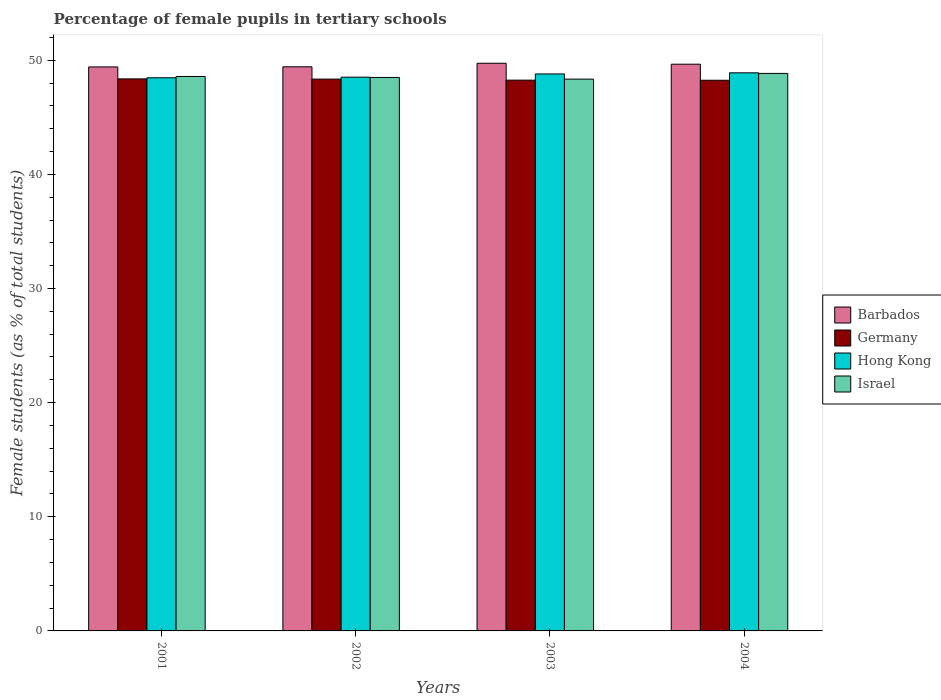How many groups of bars are there?
Ensure brevity in your answer.  4. Are the number of bars per tick equal to the number of legend labels?
Offer a terse response. Yes. How many bars are there on the 1st tick from the left?
Give a very brief answer. 4. What is the label of the 1st group of bars from the left?
Make the answer very short. 2001. In how many cases, is the number of bars for a given year not equal to the number of legend labels?
Your answer should be compact. 0. What is the percentage of female pupils in tertiary schools in Barbados in 2004?
Ensure brevity in your answer.  49.65. Across all years, what is the maximum percentage of female pupils in tertiary schools in Israel?
Your response must be concise. 48.85. Across all years, what is the minimum percentage of female pupils in tertiary schools in Barbados?
Your answer should be compact. 49.42. In which year was the percentage of female pupils in tertiary schools in Israel minimum?
Provide a succinct answer. 2003. What is the total percentage of female pupils in tertiary schools in Hong Kong in the graph?
Give a very brief answer. 194.67. What is the difference between the percentage of female pupils in tertiary schools in Israel in 2002 and that in 2004?
Provide a succinct answer. -0.35. What is the difference between the percentage of female pupils in tertiary schools in Israel in 2001 and the percentage of female pupils in tertiary schools in Barbados in 2002?
Ensure brevity in your answer.  -0.85. What is the average percentage of female pupils in tertiary schools in Israel per year?
Your answer should be compact. 48.56. In the year 2001, what is the difference between the percentage of female pupils in tertiary schools in Israel and percentage of female pupils in tertiary schools in Barbados?
Your answer should be compact. -0.84. In how many years, is the percentage of female pupils in tertiary schools in Israel greater than 16 %?
Offer a terse response. 4. What is the ratio of the percentage of female pupils in tertiary schools in Hong Kong in 2001 to that in 2004?
Provide a short and direct response. 0.99. Is the percentage of female pupils in tertiary schools in Hong Kong in 2002 less than that in 2004?
Ensure brevity in your answer.  Yes. What is the difference between the highest and the second highest percentage of female pupils in tertiary schools in Hong Kong?
Keep it short and to the point. 0.1. What is the difference between the highest and the lowest percentage of female pupils in tertiary schools in Germany?
Offer a terse response. 0.12. Is the sum of the percentage of female pupils in tertiary schools in Israel in 2002 and 2004 greater than the maximum percentage of female pupils in tertiary schools in Germany across all years?
Offer a terse response. Yes. Is it the case that in every year, the sum of the percentage of female pupils in tertiary schools in Israel and percentage of female pupils in tertiary schools in Barbados is greater than the sum of percentage of female pupils in tertiary schools in Hong Kong and percentage of female pupils in tertiary schools in Germany?
Give a very brief answer. No. How many bars are there?
Give a very brief answer. 16. Are all the bars in the graph horizontal?
Offer a terse response. No. Does the graph contain any zero values?
Give a very brief answer. No. How are the legend labels stacked?
Provide a short and direct response. Vertical. What is the title of the graph?
Provide a succinct answer. Percentage of female pupils in tertiary schools. Does "East Asia (developing only)" appear as one of the legend labels in the graph?
Make the answer very short. No. What is the label or title of the X-axis?
Your response must be concise. Years. What is the label or title of the Y-axis?
Give a very brief answer. Female students (as % of total students). What is the Female students (as % of total students) of Barbados in 2001?
Provide a succinct answer. 49.42. What is the Female students (as % of total students) of Germany in 2001?
Your response must be concise. 48.37. What is the Female students (as % of total students) of Hong Kong in 2001?
Your answer should be compact. 48.46. What is the Female students (as % of total students) in Israel in 2001?
Offer a terse response. 48.58. What is the Female students (as % of total students) of Barbados in 2002?
Offer a very short reply. 49.43. What is the Female students (as % of total students) in Germany in 2002?
Keep it short and to the point. 48.35. What is the Female students (as % of total students) of Hong Kong in 2002?
Make the answer very short. 48.51. What is the Female students (as % of total students) of Israel in 2002?
Give a very brief answer. 48.49. What is the Female students (as % of total students) in Barbados in 2003?
Keep it short and to the point. 49.74. What is the Female students (as % of total students) of Germany in 2003?
Your answer should be very brief. 48.25. What is the Female students (as % of total students) in Hong Kong in 2003?
Give a very brief answer. 48.8. What is the Female students (as % of total students) of Israel in 2003?
Give a very brief answer. 48.35. What is the Female students (as % of total students) of Barbados in 2004?
Make the answer very short. 49.65. What is the Female students (as % of total students) of Germany in 2004?
Offer a very short reply. 48.24. What is the Female students (as % of total students) in Hong Kong in 2004?
Your answer should be very brief. 48.9. What is the Female students (as % of total students) in Israel in 2004?
Keep it short and to the point. 48.85. Across all years, what is the maximum Female students (as % of total students) of Barbados?
Offer a terse response. 49.74. Across all years, what is the maximum Female students (as % of total students) in Germany?
Your answer should be very brief. 48.37. Across all years, what is the maximum Female students (as % of total students) of Hong Kong?
Offer a terse response. 48.9. Across all years, what is the maximum Female students (as % of total students) of Israel?
Give a very brief answer. 48.85. Across all years, what is the minimum Female students (as % of total students) in Barbados?
Give a very brief answer. 49.42. Across all years, what is the minimum Female students (as % of total students) of Germany?
Ensure brevity in your answer.  48.24. Across all years, what is the minimum Female students (as % of total students) of Hong Kong?
Ensure brevity in your answer.  48.46. Across all years, what is the minimum Female students (as % of total students) in Israel?
Your answer should be very brief. 48.35. What is the total Female students (as % of total students) in Barbados in the graph?
Make the answer very short. 198.23. What is the total Female students (as % of total students) in Germany in the graph?
Provide a succinct answer. 193.21. What is the total Female students (as % of total students) in Hong Kong in the graph?
Offer a terse response. 194.67. What is the total Female students (as % of total students) in Israel in the graph?
Your answer should be very brief. 194.26. What is the difference between the Female students (as % of total students) of Barbados in 2001 and that in 2002?
Give a very brief answer. -0.01. What is the difference between the Female students (as % of total students) of Germany in 2001 and that in 2002?
Keep it short and to the point. 0.02. What is the difference between the Female students (as % of total students) in Hong Kong in 2001 and that in 2002?
Give a very brief answer. -0.05. What is the difference between the Female students (as % of total students) of Israel in 2001 and that in 2002?
Your answer should be very brief. 0.08. What is the difference between the Female students (as % of total students) of Barbados in 2001 and that in 2003?
Offer a terse response. -0.32. What is the difference between the Female students (as % of total students) in Germany in 2001 and that in 2003?
Your response must be concise. 0.11. What is the difference between the Female students (as % of total students) in Hong Kong in 2001 and that in 2003?
Your answer should be very brief. -0.34. What is the difference between the Female students (as % of total students) of Israel in 2001 and that in 2003?
Provide a succinct answer. 0.23. What is the difference between the Female students (as % of total students) of Barbados in 2001 and that in 2004?
Provide a short and direct response. -0.24. What is the difference between the Female students (as % of total students) in Germany in 2001 and that in 2004?
Keep it short and to the point. 0.12. What is the difference between the Female students (as % of total students) of Hong Kong in 2001 and that in 2004?
Make the answer very short. -0.43. What is the difference between the Female students (as % of total students) of Israel in 2001 and that in 2004?
Your answer should be compact. -0.27. What is the difference between the Female students (as % of total students) in Barbados in 2002 and that in 2003?
Provide a succinct answer. -0.31. What is the difference between the Female students (as % of total students) of Germany in 2002 and that in 2003?
Offer a terse response. 0.09. What is the difference between the Female students (as % of total students) in Hong Kong in 2002 and that in 2003?
Your response must be concise. -0.28. What is the difference between the Female students (as % of total students) of Israel in 2002 and that in 2003?
Keep it short and to the point. 0.15. What is the difference between the Female students (as % of total students) of Barbados in 2002 and that in 2004?
Provide a short and direct response. -0.23. What is the difference between the Female students (as % of total students) of Germany in 2002 and that in 2004?
Your response must be concise. 0.1. What is the difference between the Female students (as % of total students) of Hong Kong in 2002 and that in 2004?
Provide a short and direct response. -0.38. What is the difference between the Female students (as % of total students) of Israel in 2002 and that in 2004?
Your answer should be compact. -0.35. What is the difference between the Female students (as % of total students) in Barbados in 2003 and that in 2004?
Offer a very short reply. 0.08. What is the difference between the Female students (as % of total students) of Germany in 2003 and that in 2004?
Offer a very short reply. 0.01. What is the difference between the Female students (as % of total students) of Hong Kong in 2003 and that in 2004?
Provide a short and direct response. -0.1. What is the difference between the Female students (as % of total students) of Israel in 2003 and that in 2004?
Offer a very short reply. -0.5. What is the difference between the Female students (as % of total students) of Barbados in 2001 and the Female students (as % of total students) of Germany in 2002?
Offer a terse response. 1.07. What is the difference between the Female students (as % of total students) of Barbados in 2001 and the Female students (as % of total students) of Hong Kong in 2002?
Make the answer very short. 0.9. What is the difference between the Female students (as % of total students) in Barbados in 2001 and the Female students (as % of total students) in Israel in 2002?
Offer a terse response. 0.92. What is the difference between the Female students (as % of total students) of Germany in 2001 and the Female students (as % of total students) of Hong Kong in 2002?
Your response must be concise. -0.15. What is the difference between the Female students (as % of total students) of Germany in 2001 and the Female students (as % of total students) of Israel in 2002?
Provide a short and direct response. -0.13. What is the difference between the Female students (as % of total students) in Hong Kong in 2001 and the Female students (as % of total students) in Israel in 2002?
Your response must be concise. -0.03. What is the difference between the Female students (as % of total students) in Barbados in 2001 and the Female students (as % of total students) in Germany in 2003?
Give a very brief answer. 1.16. What is the difference between the Female students (as % of total students) of Barbados in 2001 and the Female students (as % of total students) of Hong Kong in 2003?
Provide a short and direct response. 0.62. What is the difference between the Female students (as % of total students) of Barbados in 2001 and the Female students (as % of total students) of Israel in 2003?
Give a very brief answer. 1.07. What is the difference between the Female students (as % of total students) in Germany in 2001 and the Female students (as % of total students) in Hong Kong in 2003?
Offer a terse response. -0.43. What is the difference between the Female students (as % of total students) of Germany in 2001 and the Female students (as % of total students) of Israel in 2003?
Your answer should be very brief. 0.02. What is the difference between the Female students (as % of total students) in Hong Kong in 2001 and the Female students (as % of total students) in Israel in 2003?
Your response must be concise. 0.12. What is the difference between the Female students (as % of total students) of Barbados in 2001 and the Female students (as % of total students) of Germany in 2004?
Your response must be concise. 1.17. What is the difference between the Female students (as % of total students) of Barbados in 2001 and the Female students (as % of total students) of Hong Kong in 2004?
Provide a succinct answer. 0.52. What is the difference between the Female students (as % of total students) in Barbados in 2001 and the Female students (as % of total students) in Israel in 2004?
Make the answer very short. 0.57. What is the difference between the Female students (as % of total students) of Germany in 2001 and the Female students (as % of total students) of Hong Kong in 2004?
Your answer should be compact. -0.53. What is the difference between the Female students (as % of total students) of Germany in 2001 and the Female students (as % of total students) of Israel in 2004?
Offer a very short reply. -0.48. What is the difference between the Female students (as % of total students) of Hong Kong in 2001 and the Female students (as % of total students) of Israel in 2004?
Your response must be concise. -0.38. What is the difference between the Female students (as % of total students) in Barbados in 2002 and the Female students (as % of total students) in Germany in 2003?
Your response must be concise. 1.17. What is the difference between the Female students (as % of total students) of Barbados in 2002 and the Female students (as % of total students) of Hong Kong in 2003?
Offer a very short reply. 0.63. What is the difference between the Female students (as % of total students) of Barbados in 2002 and the Female students (as % of total students) of Israel in 2003?
Give a very brief answer. 1.08. What is the difference between the Female students (as % of total students) of Germany in 2002 and the Female students (as % of total students) of Hong Kong in 2003?
Your answer should be very brief. -0.45. What is the difference between the Female students (as % of total students) of Hong Kong in 2002 and the Female students (as % of total students) of Israel in 2003?
Your answer should be very brief. 0.17. What is the difference between the Female students (as % of total students) of Barbados in 2002 and the Female students (as % of total students) of Germany in 2004?
Make the answer very short. 1.18. What is the difference between the Female students (as % of total students) in Barbados in 2002 and the Female students (as % of total students) in Hong Kong in 2004?
Your response must be concise. 0.53. What is the difference between the Female students (as % of total students) of Barbados in 2002 and the Female students (as % of total students) of Israel in 2004?
Your answer should be very brief. 0.58. What is the difference between the Female students (as % of total students) in Germany in 2002 and the Female students (as % of total students) in Hong Kong in 2004?
Provide a short and direct response. -0.55. What is the difference between the Female students (as % of total students) in Germany in 2002 and the Female students (as % of total students) in Israel in 2004?
Offer a terse response. -0.5. What is the difference between the Female students (as % of total students) of Hong Kong in 2002 and the Female students (as % of total students) of Israel in 2004?
Keep it short and to the point. -0.33. What is the difference between the Female students (as % of total students) of Barbados in 2003 and the Female students (as % of total students) of Germany in 2004?
Give a very brief answer. 1.49. What is the difference between the Female students (as % of total students) in Barbados in 2003 and the Female students (as % of total students) in Hong Kong in 2004?
Ensure brevity in your answer.  0.84. What is the difference between the Female students (as % of total students) of Barbados in 2003 and the Female students (as % of total students) of Israel in 2004?
Provide a short and direct response. 0.89. What is the difference between the Female students (as % of total students) in Germany in 2003 and the Female students (as % of total students) in Hong Kong in 2004?
Make the answer very short. -0.64. What is the difference between the Female students (as % of total students) in Germany in 2003 and the Female students (as % of total students) in Israel in 2004?
Offer a very short reply. -0.59. What is the difference between the Female students (as % of total students) of Hong Kong in 2003 and the Female students (as % of total students) of Israel in 2004?
Give a very brief answer. -0.05. What is the average Female students (as % of total students) of Barbados per year?
Offer a terse response. 49.56. What is the average Female students (as % of total students) in Germany per year?
Offer a very short reply. 48.3. What is the average Female students (as % of total students) of Hong Kong per year?
Ensure brevity in your answer.  48.67. What is the average Female students (as % of total students) in Israel per year?
Provide a short and direct response. 48.56. In the year 2001, what is the difference between the Female students (as % of total students) of Barbados and Female students (as % of total students) of Germany?
Offer a very short reply. 1.05. In the year 2001, what is the difference between the Female students (as % of total students) of Barbados and Female students (as % of total students) of Hong Kong?
Offer a terse response. 0.95. In the year 2001, what is the difference between the Female students (as % of total students) in Barbados and Female students (as % of total students) in Israel?
Ensure brevity in your answer.  0.84. In the year 2001, what is the difference between the Female students (as % of total students) in Germany and Female students (as % of total students) in Hong Kong?
Give a very brief answer. -0.1. In the year 2001, what is the difference between the Female students (as % of total students) in Germany and Female students (as % of total students) in Israel?
Provide a succinct answer. -0.21. In the year 2001, what is the difference between the Female students (as % of total students) of Hong Kong and Female students (as % of total students) of Israel?
Make the answer very short. -0.11. In the year 2002, what is the difference between the Female students (as % of total students) of Barbados and Female students (as % of total students) of Germany?
Your answer should be compact. 1.08. In the year 2002, what is the difference between the Female students (as % of total students) in Barbados and Female students (as % of total students) in Hong Kong?
Your answer should be compact. 0.91. In the year 2002, what is the difference between the Female students (as % of total students) in Germany and Female students (as % of total students) in Hong Kong?
Provide a short and direct response. -0.17. In the year 2002, what is the difference between the Female students (as % of total students) in Germany and Female students (as % of total students) in Israel?
Offer a terse response. -0.14. In the year 2002, what is the difference between the Female students (as % of total students) of Hong Kong and Female students (as % of total students) of Israel?
Offer a terse response. 0.02. In the year 2003, what is the difference between the Female students (as % of total students) of Barbados and Female students (as % of total students) of Germany?
Provide a short and direct response. 1.48. In the year 2003, what is the difference between the Female students (as % of total students) of Barbados and Female students (as % of total students) of Hong Kong?
Offer a very short reply. 0.94. In the year 2003, what is the difference between the Female students (as % of total students) of Barbados and Female students (as % of total students) of Israel?
Offer a very short reply. 1.39. In the year 2003, what is the difference between the Female students (as % of total students) in Germany and Female students (as % of total students) in Hong Kong?
Your response must be concise. -0.54. In the year 2003, what is the difference between the Female students (as % of total students) of Germany and Female students (as % of total students) of Israel?
Your answer should be compact. -0.09. In the year 2003, what is the difference between the Female students (as % of total students) of Hong Kong and Female students (as % of total students) of Israel?
Your answer should be very brief. 0.45. In the year 2004, what is the difference between the Female students (as % of total students) in Barbados and Female students (as % of total students) in Germany?
Offer a very short reply. 1.41. In the year 2004, what is the difference between the Female students (as % of total students) in Barbados and Female students (as % of total students) in Hong Kong?
Your answer should be very brief. 0.76. In the year 2004, what is the difference between the Female students (as % of total students) in Barbados and Female students (as % of total students) in Israel?
Provide a succinct answer. 0.81. In the year 2004, what is the difference between the Female students (as % of total students) of Germany and Female students (as % of total students) of Hong Kong?
Your answer should be very brief. -0.65. In the year 2004, what is the difference between the Female students (as % of total students) of Germany and Female students (as % of total students) of Israel?
Give a very brief answer. -0.6. In the year 2004, what is the difference between the Female students (as % of total students) of Hong Kong and Female students (as % of total students) of Israel?
Provide a short and direct response. 0.05. What is the ratio of the Female students (as % of total students) in Barbados in 2001 to that in 2002?
Ensure brevity in your answer.  1. What is the ratio of the Female students (as % of total students) in Israel in 2001 to that in 2002?
Provide a short and direct response. 1. What is the ratio of the Female students (as % of total students) in Barbados in 2001 to that in 2003?
Offer a very short reply. 0.99. What is the ratio of the Female students (as % of total students) of Germany in 2001 to that in 2003?
Ensure brevity in your answer.  1. What is the ratio of the Female students (as % of total students) of Israel in 2001 to that in 2003?
Offer a very short reply. 1. What is the ratio of the Female students (as % of total students) in Germany in 2001 to that in 2004?
Offer a terse response. 1. What is the ratio of the Female students (as % of total students) in Hong Kong in 2001 to that in 2004?
Make the answer very short. 0.99. What is the ratio of the Female students (as % of total students) in Israel in 2001 to that in 2004?
Offer a very short reply. 0.99. What is the ratio of the Female students (as % of total students) in Germany in 2002 to that in 2004?
Your answer should be very brief. 1. What is the ratio of the Female students (as % of total students) of Hong Kong in 2002 to that in 2004?
Provide a succinct answer. 0.99. What is the ratio of the Female students (as % of total students) of Israel in 2002 to that in 2004?
Provide a short and direct response. 0.99. What is the ratio of the Female students (as % of total students) in Barbados in 2003 to that in 2004?
Keep it short and to the point. 1. What is the ratio of the Female students (as % of total students) in Germany in 2003 to that in 2004?
Your response must be concise. 1. What is the difference between the highest and the second highest Female students (as % of total students) of Barbados?
Provide a short and direct response. 0.08. What is the difference between the highest and the second highest Female students (as % of total students) in Germany?
Make the answer very short. 0.02. What is the difference between the highest and the second highest Female students (as % of total students) of Hong Kong?
Your answer should be very brief. 0.1. What is the difference between the highest and the second highest Female students (as % of total students) of Israel?
Provide a succinct answer. 0.27. What is the difference between the highest and the lowest Female students (as % of total students) of Barbados?
Your answer should be very brief. 0.32. What is the difference between the highest and the lowest Female students (as % of total students) in Germany?
Your answer should be compact. 0.12. What is the difference between the highest and the lowest Female students (as % of total students) in Hong Kong?
Offer a very short reply. 0.43. What is the difference between the highest and the lowest Female students (as % of total students) of Israel?
Offer a very short reply. 0.5. 